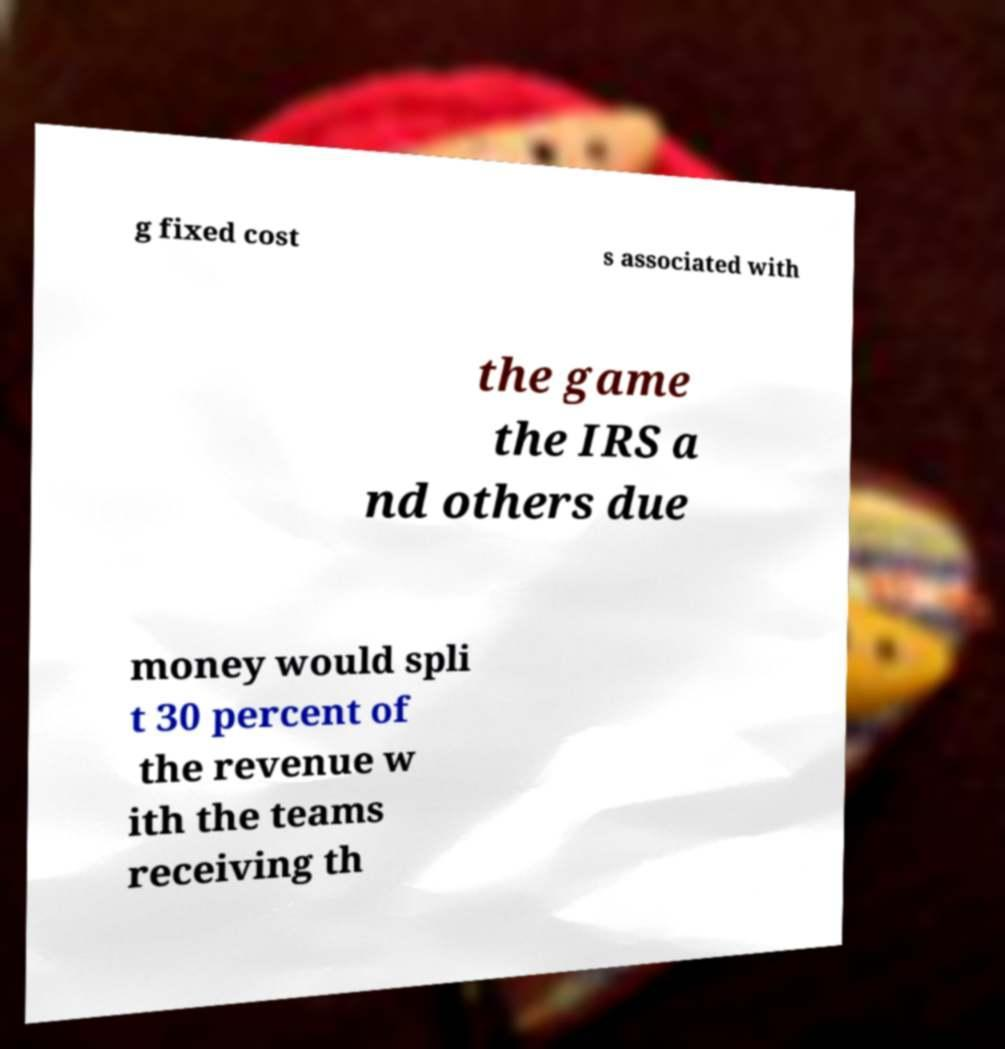Please read and relay the text visible in this image. What does it say? g fixed cost s associated with the game the IRS a nd others due money would spli t 30 percent of the revenue w ith the teams receiving th 